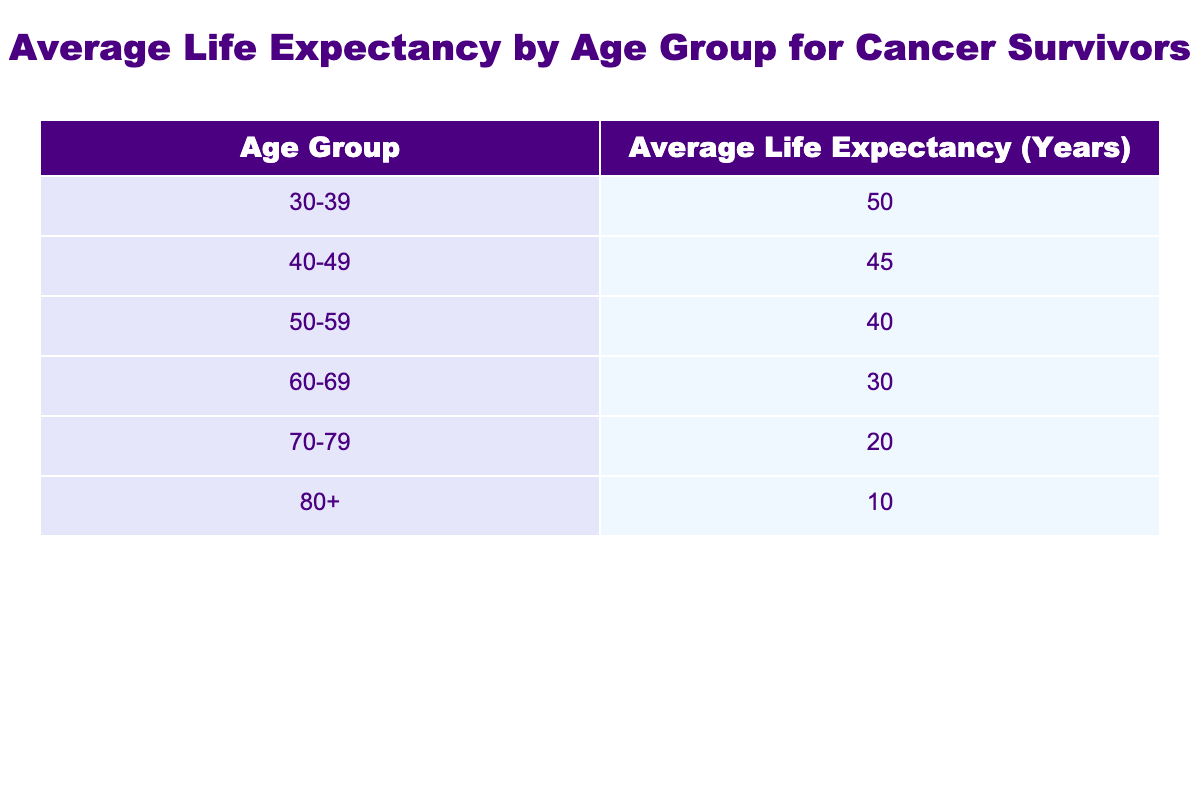What is the average life expectancy for cancer survivors aged 30-39? The table shows that the average life expectancy for the age group 30-39 is 50 years.
Answer: 50 Which age group has the lowest average life expectancy? The table indicates that the age group 80+ has the lowest average life expectancy at 10 years.
Answer: 80+ What is the difference in average life expectancy between the 40-49 and 60-69 age groups? For the age group 40-49, the average life expectancy is 45 years, while for 60-69, it is 30 years. The difference is 45 - 30 = 15 years.
Answer: 15 Is it true that cancer survivors aged 70-79 have a longer average life expectancy than those aged 60-69? The average life expectancy for the 70-79 age group is 20 years, while for the 60-69 group, it is 30 years. Therefore, it is false that the 70-79 group has a longer average life expectancy.
Answer: No If we consider the age groups 30-39, 40-49, and 50-59, what is the average life expectancy for these groups combined? The average life expectancies for these groups are 50 years, 45 years, and 40 years. We calculate the average by summing these values: 50 + 45 + 40 = 135 years. There are 3 groups, so the average is 135 / 3 = 45 years.
Answer: 45 How does the average life expectancy for the group 50-59 compare to the average for the entire table? To find this, first calculate the overall average life expectancy. The average values from all groups sum to 50 + 45 + 40 + 30 + 20 + 10 = 225 years. With 6 groups, the overall average is 225 / 6 = 37.5 years. The group 50-59 has an average of 40 years, which is higher than the overall average.
Answer: Higher What is the combined average life expectancy for cancer survivors aged 60 and above? The relevant age groups are 60-69, 70-79, and 80+. Their average life expectancies are 30, 20, and 10 years respectively. The total for these three groups is 30 + 20 + 10 = 60 years. The average for these 3 groups is 60 / 3 = 20 years.
Answer: 20 Is the average life expectancy of cancer survivors aged 40-49 greater than that of those aged 70-79? The average for 40-49 is 45 years, while for 70-79 it is 20 years. Since 45 is greater than 20, it is true that the average for 40-49 is greater.
Answer: Yes 